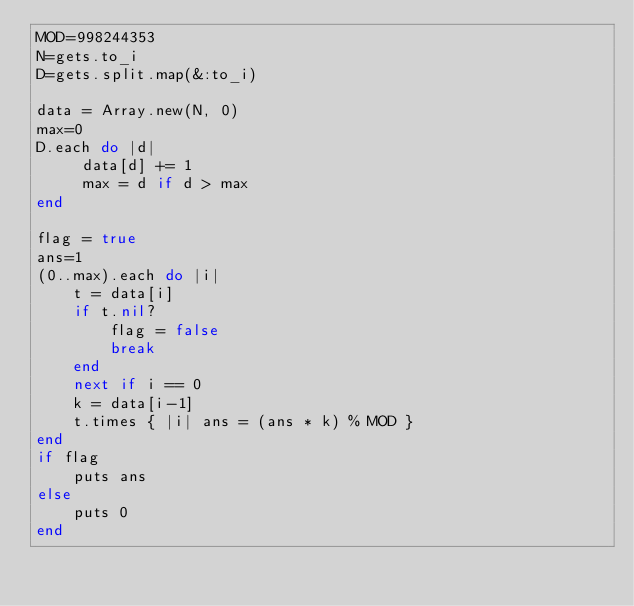<code> <loc_0><loc_0><loc_500><loc_500><_Ruby_>MOD=998244353
N=gets.to_i
D=gets.split.map(&:to_i)

data = Array.new(N, 0)
max=0
D.each do |d|
     data[d] += 1
     max = d if d > max
end

flag = true
ans=1
(0..max).each do |i|
    t = data[i]
    if t.nil?
        flag = false
        break
    end
    next if i == 0
    k = data[i-1]
    t.times { |i| ans = (ans * k) % MOD }
end
if flag
    puts ans
else
    puts 0
end
</code> 